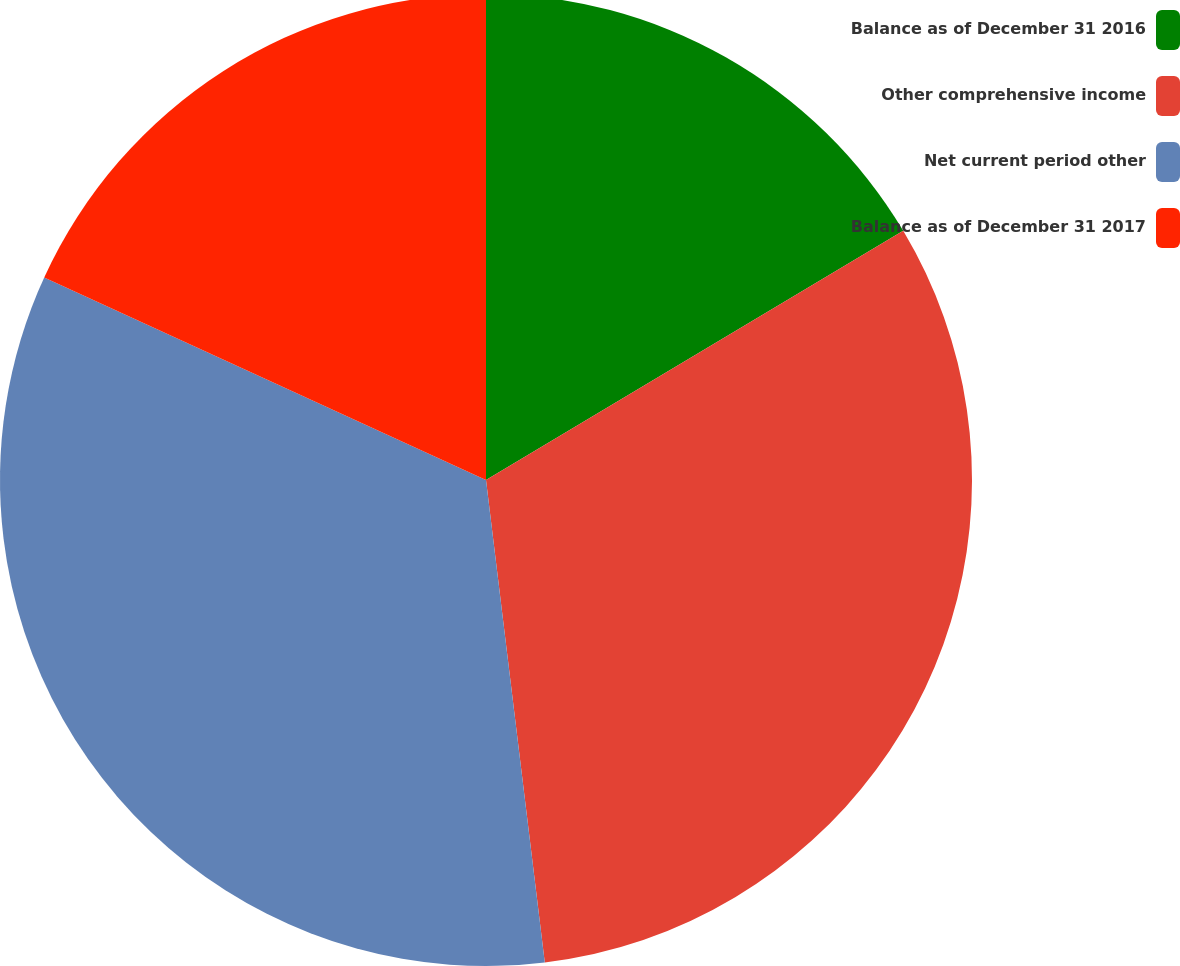Convert chart to OTSL. <chart><loc_0><loc_0><loc_500><loc_500><pie_chart><fcel>Balance as of December 31 2016<fcel>Other comprehensive income<fcel>Net current period other<fcel>Balance as of December 31 2017<nl><fcel>16.43%<fcel>31.64%<fcel>33.77%<fcel>18.16%<nl></chart> 